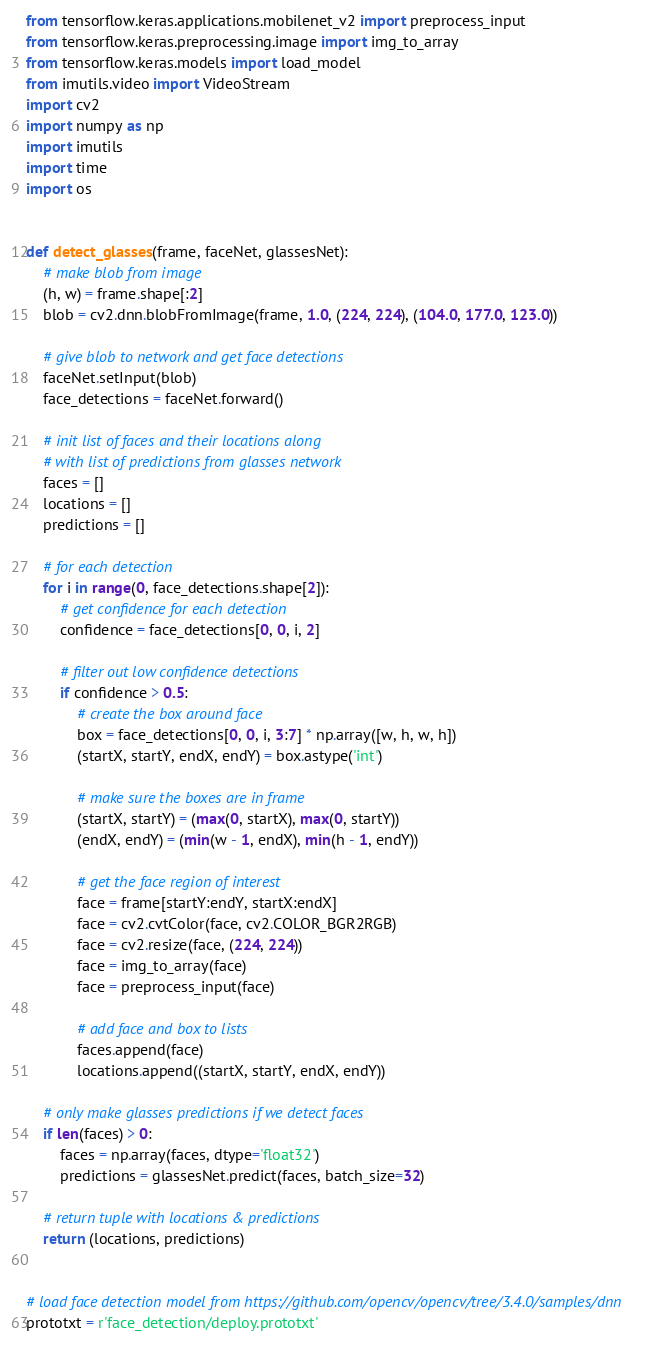Convert code to text. <code><loc_0><loc_0><loc_500><loc_500><_Python_>from tensorflow.keras.applications.mobilenet_v2 import preprocess_input
from tensorflow.keras.preprocessing.image import img_to_array
from tensorflow.keras.models import load_model
from imutils.video import VideoStream
import cv2
import numpy as np
import imutils
import time
import os


def detect_glasses(frame, faceNet, glassesNet):
    # make blob from image
    (h, w) = frame.shape[:2]
    blob = cv2.dnn.blobFromImage(frame, 1.0, (224, 224), (104.0, 177.0, 123.0))

    # give blob to network and get face detections
    faceNet.setInput(blob)
    face_detections = faceNet.forward()

    # init list of faces and their locations along
    # with list of predictions from glasses network
    faces = []
    locations = []
    predictions = []

    # for each detection
    for i in range(0, face_detections.shape[2]):
        # get confidence for each detection
        confidence = face_detections[0, 0, i, 2]

        # filter out low confidence detections
        if confidence > 0.5:
            # create the box around face
            box = face_detections[0, 0, i, 3:7] * np.array([w, h, w, h])
            (startX, startY, endX, endY) = box.astype('int')

            # make sure the boxes are in frame
            (startX, startY) = (max(0, startX), max(0, startY))
            (endX, endY) = (min(w - 1, endX), min(h - 1, endY))

            # get the face region of interest
            face = frame[startY:endY, startX:endX]
            face = cv2.cvtColor(face, cv2.COLOR_BGR2RGB)
            face = cv2.resize(face, (224, 224))
            face = img_to_array(face)
            face = preprocess_input(face)

            # add face and box to lists
            faces.append(face)
            locations.append((startX, startY, endX, endY))

    # only make glasses predictions if we detect faces
    if len(faces) > 0:
        faces = np.array(faces, dtype='float32')
        predictions = glassesNet.predict(faces, batch_size=32)

    # return tuple with locations & predictions
    return (locations, predictions)


# load face detection model from https://github.com/opencv/opencv/tree/3.4.0/samples/dnn
prototxt = r'face_detection/deploy.prototxt'</code> 